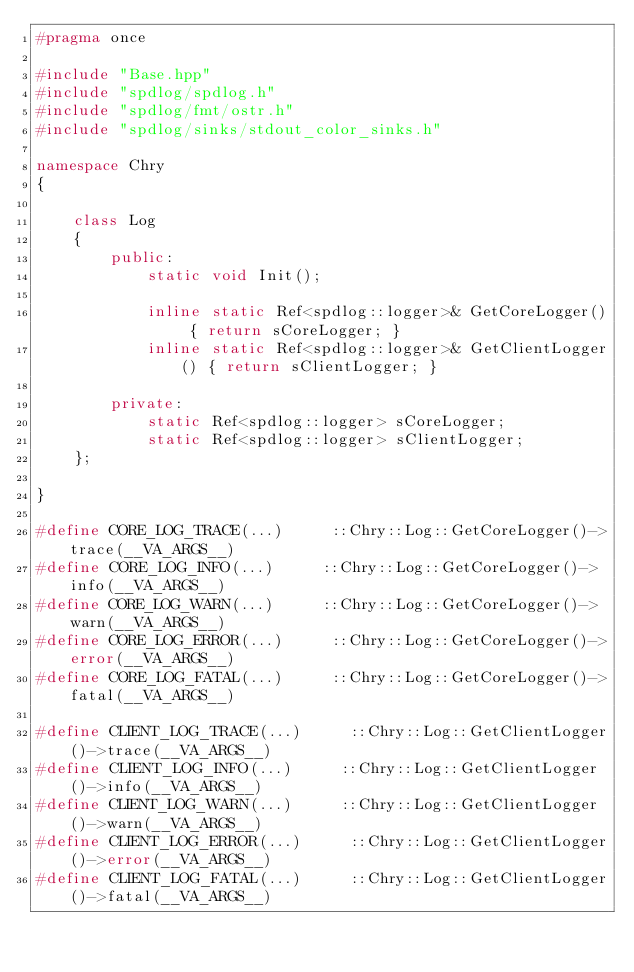<code> <loc_0><loc_0><loc_500><loc_500><_C++_>#pragma once

#include "Base.hpp"
#include "spdlog/spdlog.h"
#include "spdlog/fmt/ostr.h"
#include "spdlog/sinks/stdout_color_sinks.h"

namespace Chry
{

    class Log
    {
        public:
            static void Init();

            inline static Ref<spdlog::logger>& GetCoreLogger() { return sCoreLogger; }
            inline static Ref<spdlog::logger>& GetClientLogger() { return sClientLogger; }

        private:
            static Ref<spdlog::logger> sCoreLogger;
            static Ref<spdlog::logger> sClientLogger;
    };

}

#define CORE_LOG_TRACE(...)     ::Chry::Log::GetCoreLogger()->trace(__VA_ARGS__)
#define CORE_LOG_INFO(...)     ::Chry::Log::GetCoreLogger()->info(__VA_ARGS__)
#define CORE_LOG_WARN(...)     ::Chry::Log::GetCoreLogger()->warn(__VA_ARGS__)
#define CORE_LOG_ERROR(...)     ::Chry::Log::GetCoreLogger()->error(__VA_ARGS__)
#define CORE_LOG_FATAL(...)     ::Chry::Log::GetCoreLogger()->fatal(__VA_ARGS__)

#define CLIENT_LOG_TRACE(...)     ::Chry::Log::GetClientLogger()->trace(__VA_ARGS__)
#define CLIENT_LOG_INFO(...)     ::Chry::Log::GetClientLogger()->info(__VA_ARGS__)
#define CLIENT_LOG_WARN(...)     ::Chry::Log::GetClientLogger()->warn(__VA_ARGS__)
#define CLIENT_LOG_ERROR(...)     ::Chry::Log::GetClientLogger()->error(__VA_ARGS__)
#define CLIENT_LOG_FATAL(...)     ::Chry::Log::GetClientLogger()->fatal(__VA_ARGS__)
</code> 